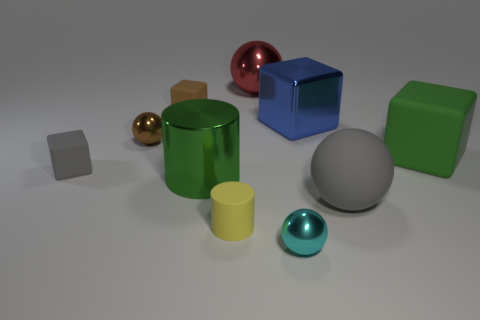Subtract 1 blocks. How many blocks are left? 3 Subtract all balls. How many objects are left? 6 Add 8 blue blocks. How many blue blocks are left? 9 Add 6 gray cubes. How many gray cubes exist? 7 Subtract 0 yellow cubes. How many objects are left? 10 Subtract all gray things. Subtract all green metal things. How many objects are left? 7 